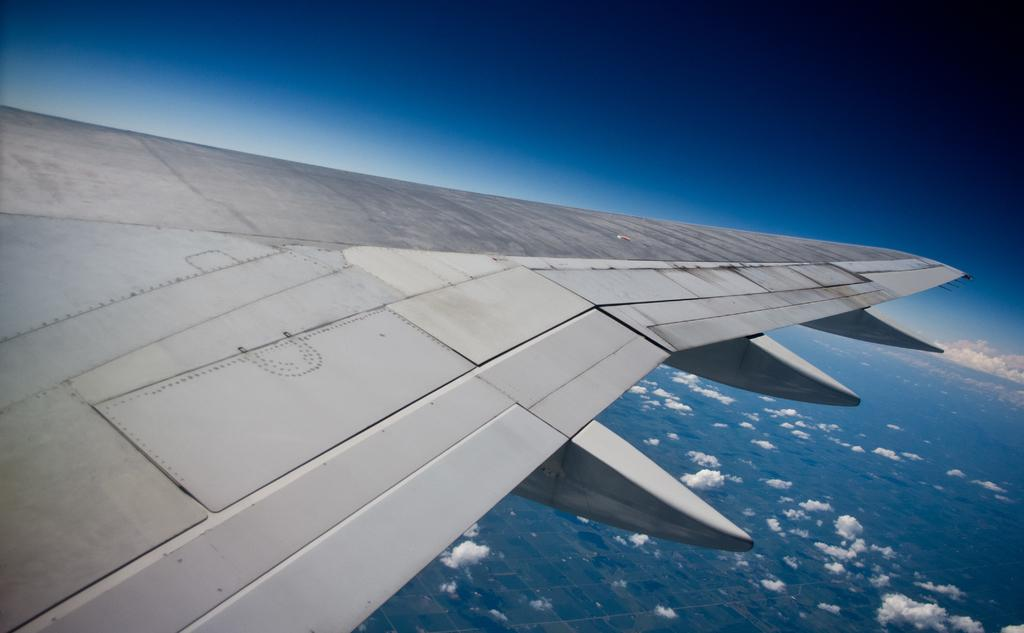What is the main subject of the image? The main subject of the image is a wing part of an airplane. What can be seen in the background of the image? There are clouds in the sky in the image. How many geese are flying alongside the airplane wing in the image? There are no geese present in the image; it only features the wing part of an airplane. What does the mom of the person who took the image think about the airplane wing? The provided facts do not give any information about the person who took the image or their mom, so we cannot answer this question. 